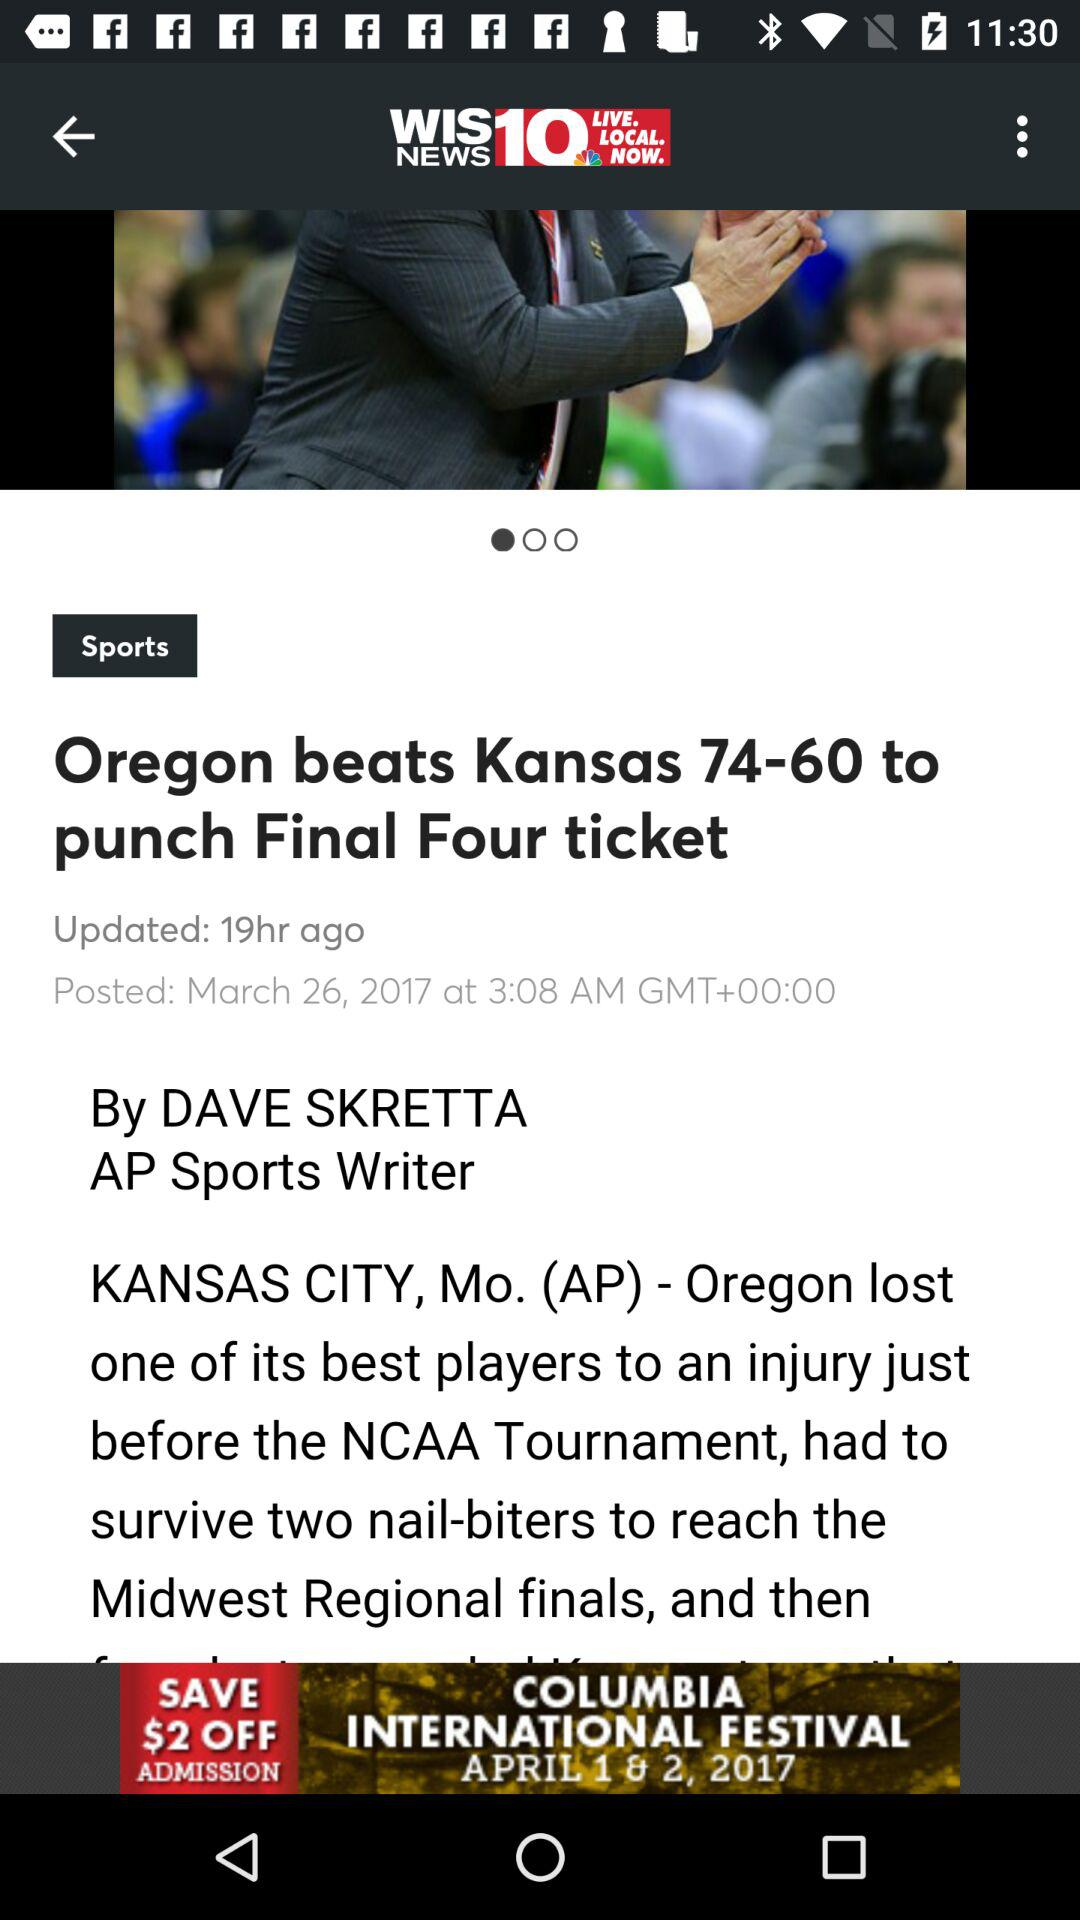When was the news updated? The news was updated 19 hours ago. 